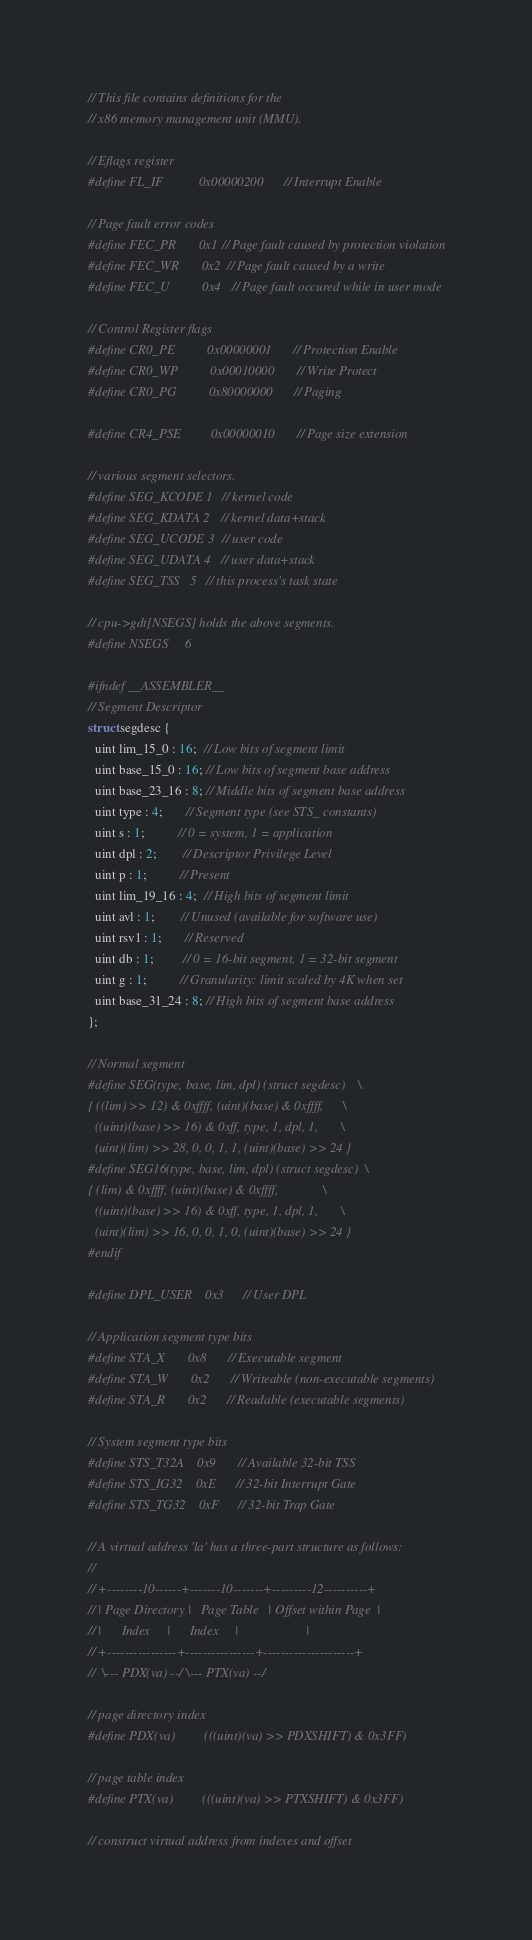<code> <loc_0><loc_0><loc_500><loc_500><_C_>// This file contains definitions for the
// x86 memory management unit (MMU).

// Eflags register
#define FL_IF           0x00000200      // Interrupt Enable

// Page fault error codes
#define FEC_PR		0x1	// Page fault caused by protection violation
#define FEC_WR		0x2	// Page fault caused by a write
#define FEC_U		  0x4	// Page fault occured while in user mode

// Control Register flags
#define CR0_PE          0x00000001      // Protection Enable
#define CR0_WP          0x00010000      // Write Protect
#define CR0_PG          0x80000000      // Paging

#define CR4_PSE         0x00000010      // Page size extension

// various segment selectors.
#define SEG_KCODE 1  // kernel code
#define SEG_KDATA 2  // kernel data+stack
#define SEG_UCODE 3  // user code
#define SEG_UDATA 4  // user data+stack
#define SEG_TSS   5  // this process's task state

// cpu->gdt[NSEGS] holds the above segments.
#define NSEGS     6

#ifndef __ASSEMBLER__
// Segment Descriptor
struct segdesc {
  uint lim_15_0 : 16;  // Low bits of segment limit
  uint base_15_0 : 16; // Low bits of segment base address
  uint base_23_16 : 8; // Middle bits of segment base address
  uint type : 4;       // Segment type (see STS_ constants)
  uint s : 1;          // 0 = system, 1 = application
  uint dpl : 2;        // Descriptor Privilege Level
  uint p : 1;          // Present
  uint lim_19_16 : 4;  // High bits of segment limit
  uint avl : 1;        // Unused (available for software use)
  uint rsv1 : 1;       // Reserved
  uint db : 1;         // 0 = 16-bit segment, 1 = 32-bit segment
  uint g : 1;          // Granularity: limit scaled by 4K when set
  uint base_31_24 : 8; // High bits of segment base address
};

// Normal segment
#define SEG(type, base, lim, dpl) (struct segdesc)    \
{ ((lim) >> 12) & 0xffff, (uint)(base) & 0xffff,      \
  ((uint)(base) >> 16) & 0xff, type, 1, dpl, 1,       \
  (uint)(lim) >> 28, 0, 0, 1, 1, (uint)(base) >> 24 }
#define SEG16(type, base, lim, dpl) (struct segdesc)  \
{ (lim) & 0xffff, (uint)(base) & 0xffff,              \
  ((uint)(base) >> 16) & 0xff, type, 1, dpl, 1,       \
  (uint)(lim) >> 16, 0, 0, 1, 0, (uint)(base) >> 24 }
#endif

#define DPL_USER    0x3     // User DPL

// Application segment type bits
#define STA_X       0x8     // Executable segment
#define STA_W       0x2     // Writeable (non-executable segments)
#define STA_R       0x2     // Readable (executable segments)

// System segment type bits
#define STS_T32A    0x9     // Available 32-bit TSS
#define STS_IG32    0xE     // 32-bit Interrupt Gate
#define STS_TG32    0xF     // 32-bit Trap Gate

// A virtual address 'la' has a three-part structure as follows:
//
// +--------10------+-------10-------+---------12----------+
// | Page Directory |   Page Table   | Offset within Page  |
// |      Index     |      Index     |                     |
// +----------------+----------------+---------------------+
//  \--- PDX(va) --/ \--- PTX(va) --/

// page directory index
#define PDX(va)         (((uint)(va) >> PDXSHIFT) & 0x3FF)

// page table index
#define PTX(va)         (((uint)(va) >> PTXSHIFT) & 0x3FF)

// construct virtual address from indexes and offset</code> 